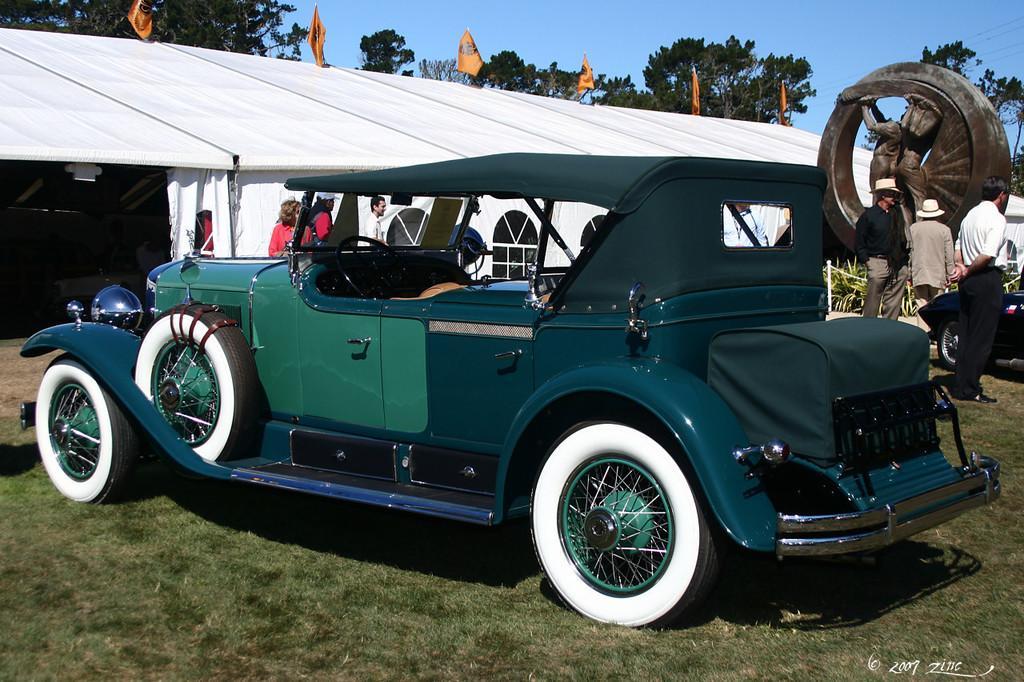In one or two sentences, can you explain what this image depicts? In this image in the center there is one vehicle, in the background there are some persons and tent. On the text there are some flags and poles and in the background there are some trees and sky, at the bottom there is grass. 